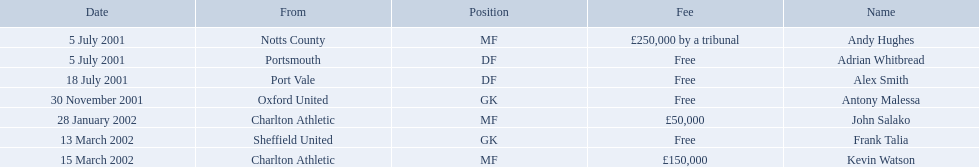List all the players names Andy Hughes, Adrian Whitbread, Alex Smith, Antony Malessa, John Salako, Frank Talia, Kevin Watson. Of these who is kevin watson Kevin Watson. To what transfer fee entry does kevin correspond to? £150,000. 